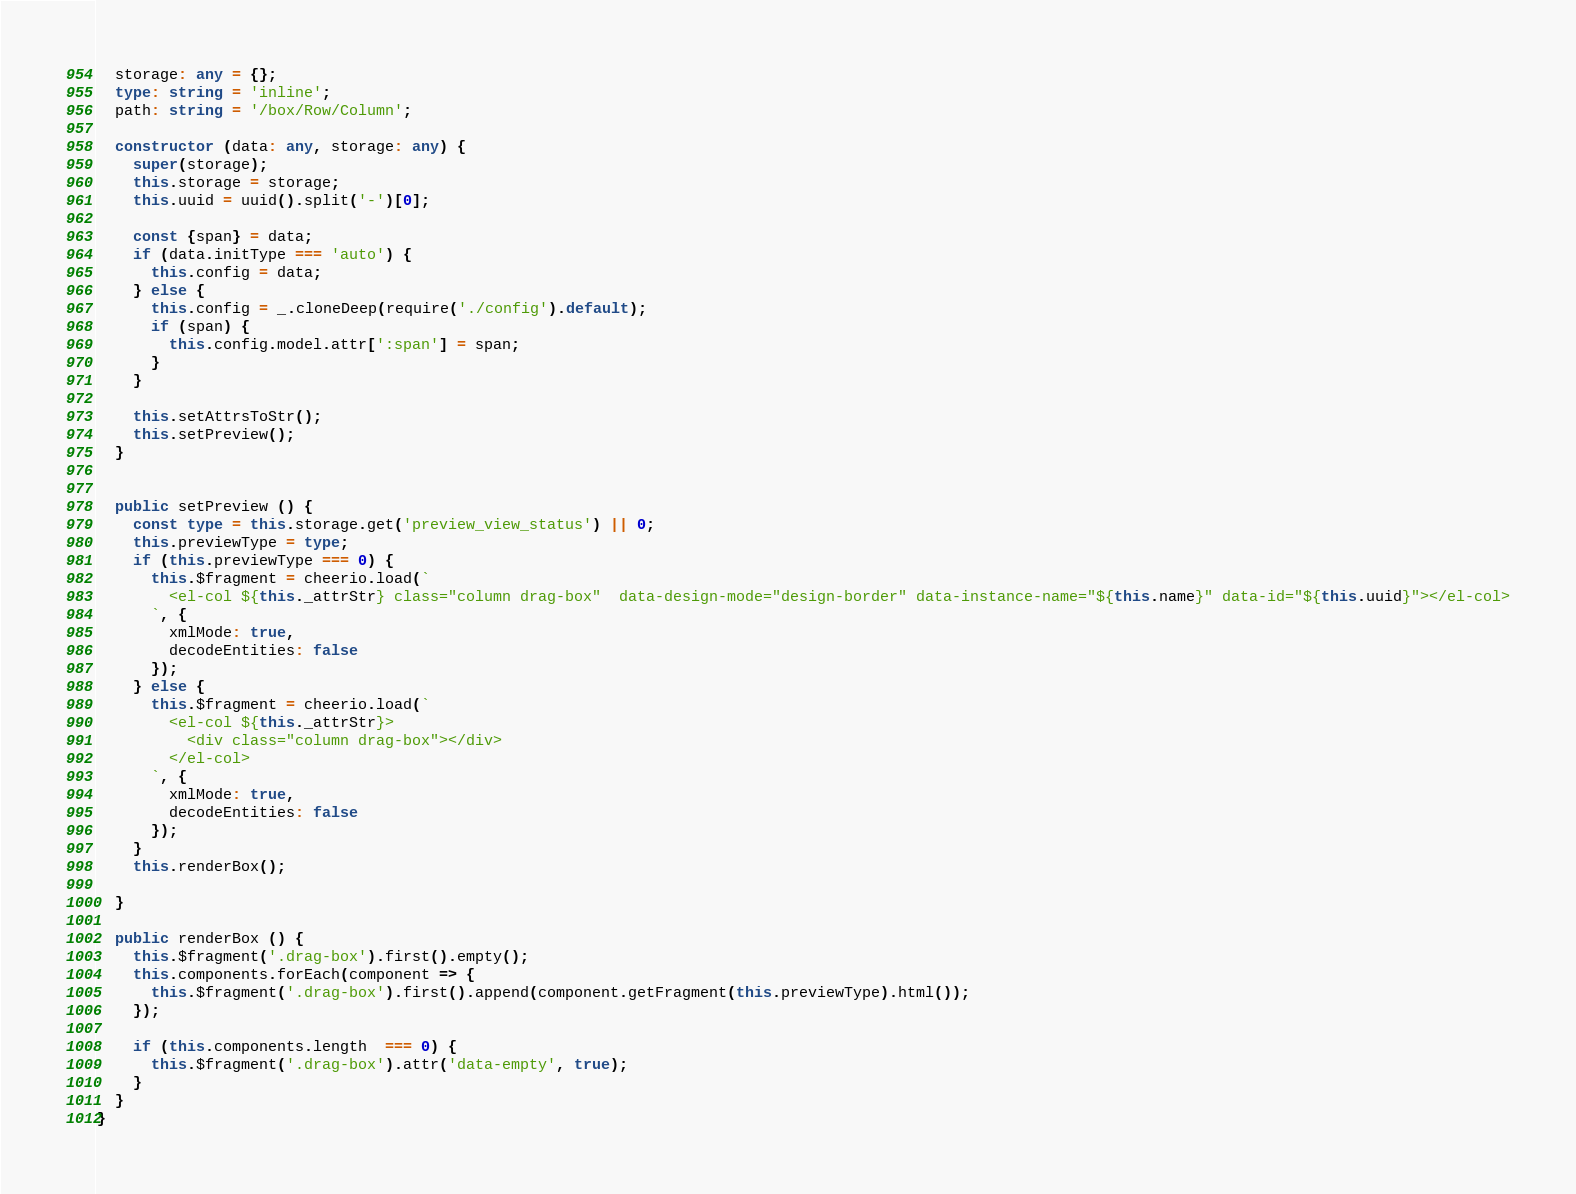<code> <loc_0><loc_0><loc_500><loc_500><_TypeScript_>  storage: any = {};
  type: string = 'inline';
  path: string = '/box/Row/Column';

  constructor (data: any, storage: any) {
    super(storage);
    this.storage = storage;
    this.uuid = uuid().split('-')[0]; 

    const {span} = data;
    if (data.initType === 'auto') {
      this.config = data;
    } else {
      this.config = _.cloneDeep(require('./config').default);
      if (span) {
        this.config.model.attr[':span'] = span;
      }
    }
    
    this.setAttrsToStr();
    this.setPreview();
  }


  public setPreview () {
    const type = this.storage.get('preview_view_status') || 0;
    this.previewType = type;
    if (this.previewType === 0) {
      this.$fragment = cheerio.load(`
        <el-col ${this._attrStr} class="column drag-box"  data-design-mode="design-border" data-instance-name="${this.name}" data-id="${this.uuid}"></el-col>
      `, {
        xmlMode: true,
        decodeEntities: false
      });
    } else {
      this.$fragment = cheerio.load(`
        <el-col ${this._attrStr}>
          <div class="column drag-box"></div>
        </el-col>
      `, {
        xmlMode: true,
        decodeEntities: false
      });
    }
    this.renderBox();

  }  

  public renderBox () {
    this.$fragment('.drag-box').first().empty();
    this.components.forEach(component => {
      this.$fragment('.drag-box').first().append(component.getFragment(this.previewType).html());
    });

    if (this.components.length  === 0) {
      this.$fragment('.drag-box').attr('data-empty', true);
    }
  }
}</code> 